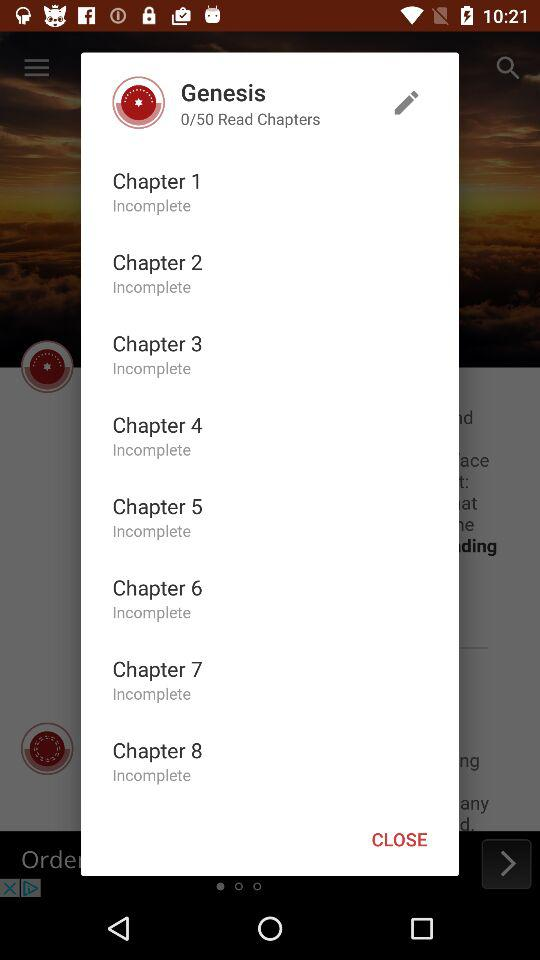How many total chapters are there? There are a total of 50 chapters. 